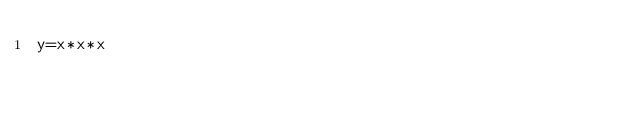Convert code to text. <code><loc_0><loc_0><loc_500><loc_500><_C_>y=x*x*x</code> 